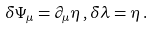<formula> <loc_0><loc_0><loc_500><loc_500>\delta \Psi _ { \mu } = \partial _ { \mu } \eta \, , \delta \lambda = \eta \, .</formula> 